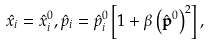<formula> <loc_0><loc_0><loc_500><loc_500>\hat { x } _ { i } = \hat { x } ^ { 0 } _ { i } , \hat { p } _ { i } = \hat { p } ^ { 0 } _ { i } \left [ 1 + { \beta } \left ( \hat { \mathbf p } ^ { 0 } \right ) ^ { 2 } \right ] ,</formula> 